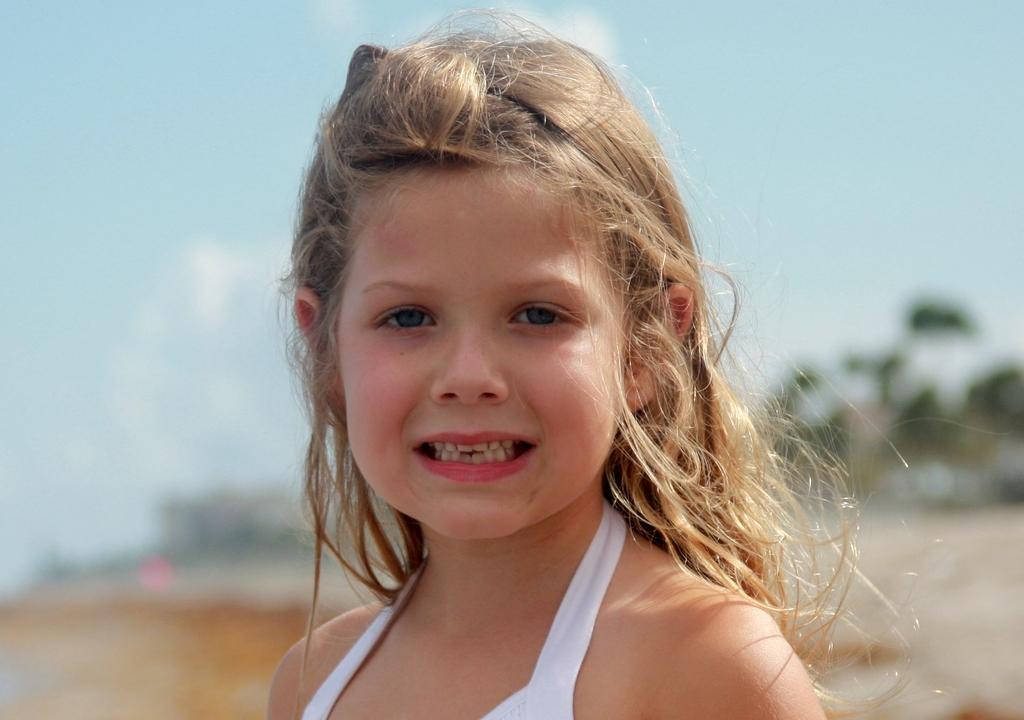Who is the main subject in the image? There is a small girl in the center of the image. What can be seen in the background of the image? There are trees and the sky visible in the background of the image. What color is the dress the small girl is wearing in the image? The provided facts do not mention the color of the girl's dress, nor does the image show any dress. 